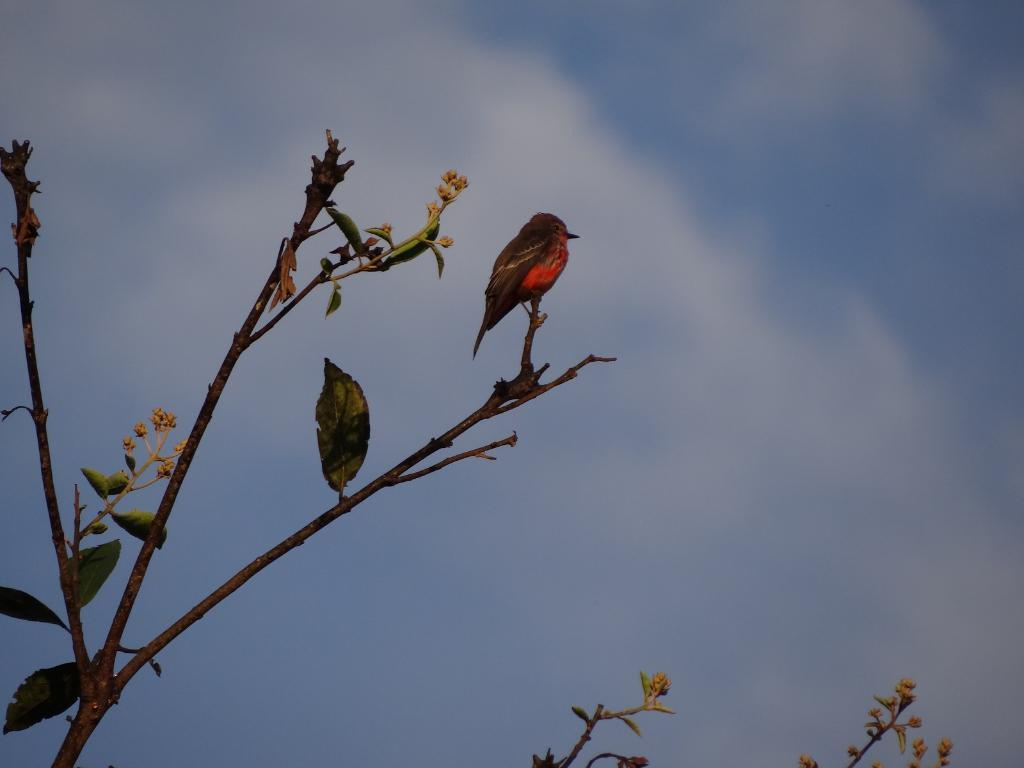What type of animal is in the image? There is a bird in the image. Where is the bird located in the image? The bird is on a tree branch. What is the color and condition of the sky in the image? The sky is blue and cloudy in the image. Can you see the ocean in the image? There is no ocean present in the image. What type of yam is the bird holding in its beak? The bird is not holding any yam in its beak; it is on a tree branch. 